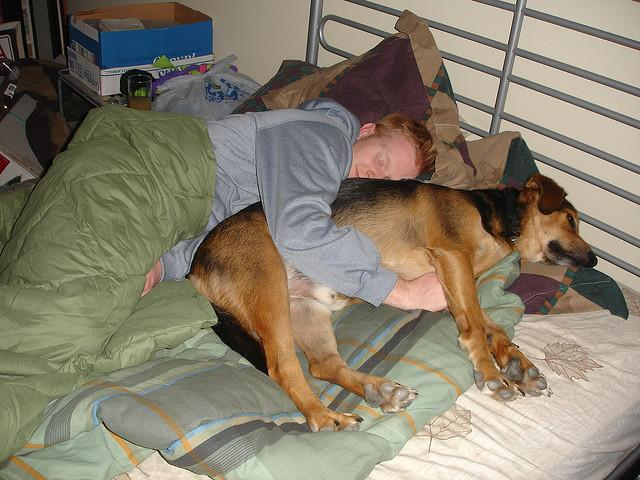What is the owner giving his dog? hug 